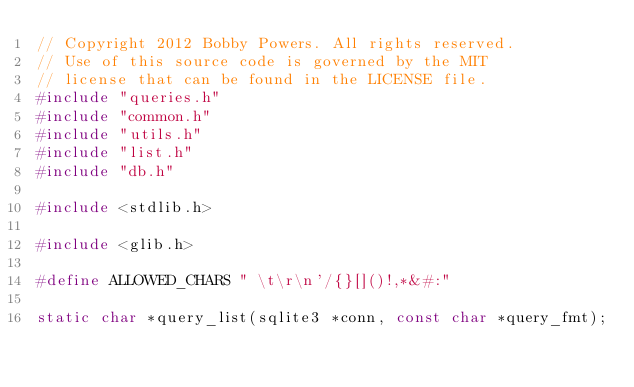<code> <loc_0><loc_0><loc_500><loc_500><_C_>// Copyright 2012 Bobby Powers. All rights reserved.
// Use of this source code is governed by the MIT
// license that can be found in the LICENSE file.
#include "queries.h"
#include "common.h"
#include "utils.h"
#include "list.h"
#include "db.h"

#include <stdlib.h>

#include <glib.h>

#define ALLOWED_CHARS " \t\r\n'/{}[]()!,*&#:"

static char *query_list(sqlite3 *conn, const char *query_fmt);</code> 